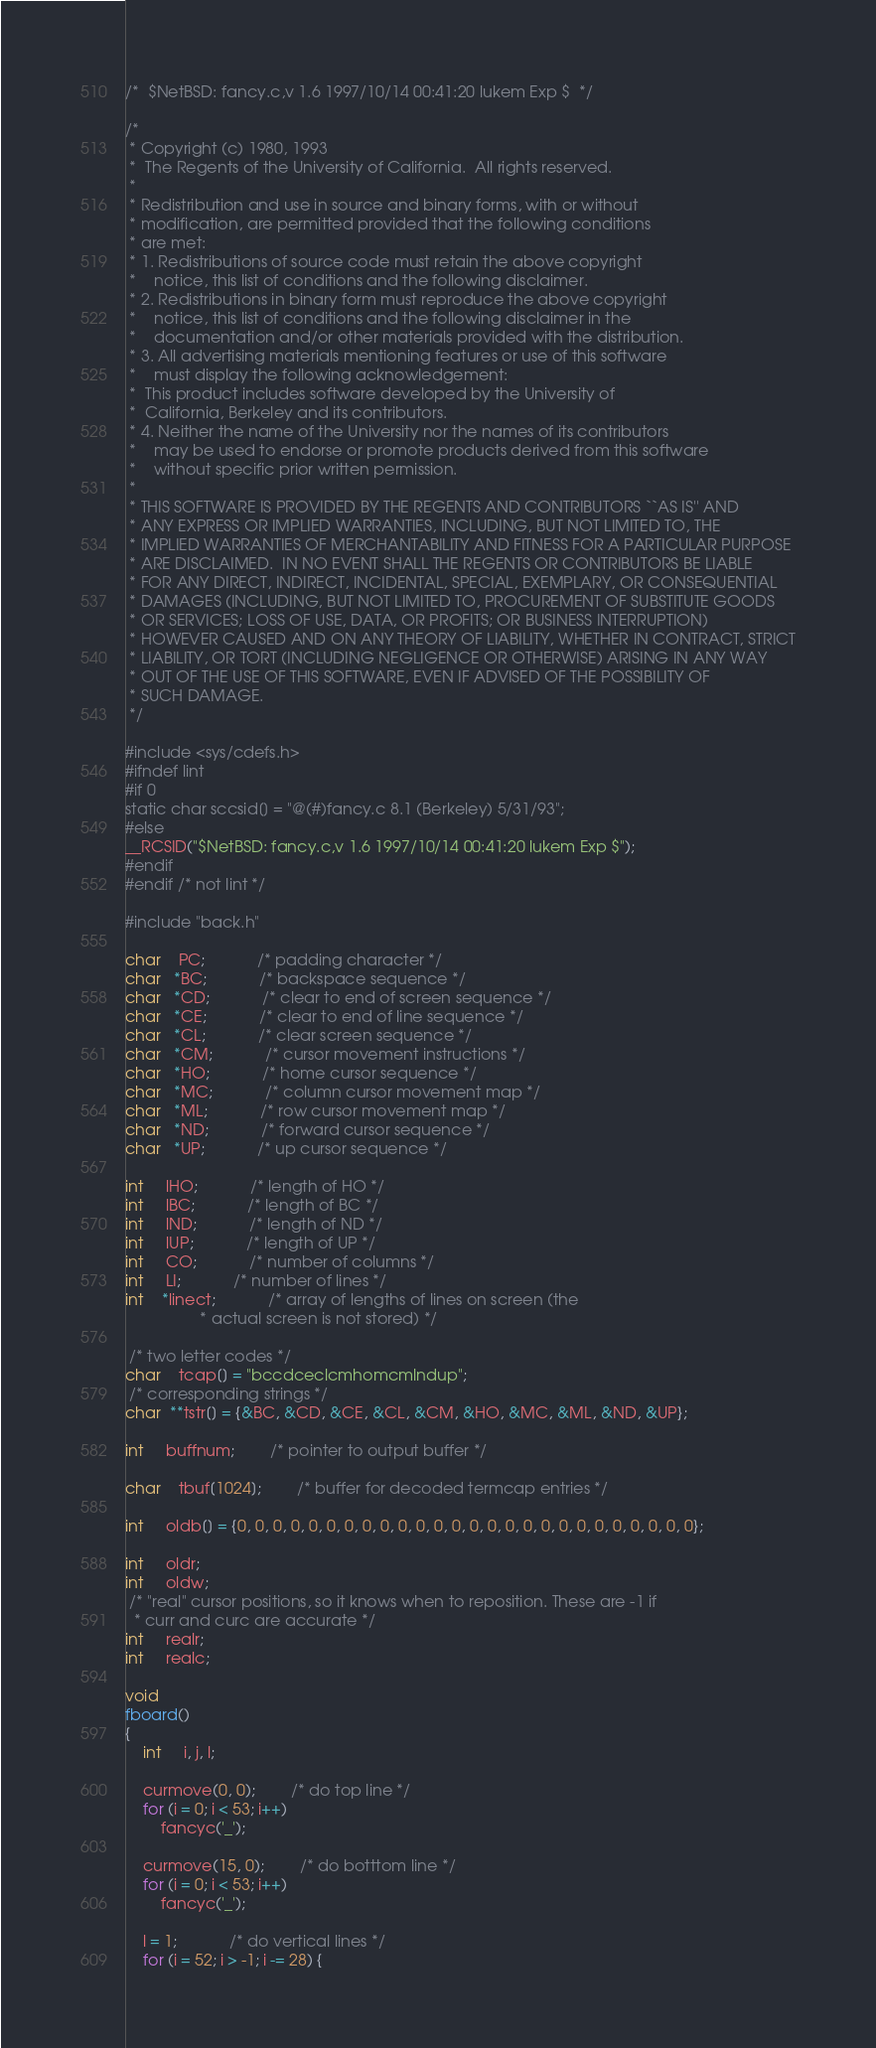<code> <loc_0><loc_0><loc_500><loc_500><_C_>/*	$NetBSD: fancy.c,v 1.6 1997/10/14 00:41:20 lukem Exp $	*/

/*
 * Copyright (c) 1980, 1993
 *	The Regents of the University of California.  All rights reserved.
 *
 * Redistribution and use in source and binary forms, with or without
 * modification, are permitted provided that the following conditions
 * are met:
 * 1. Redistributions of source code must retain the above copyright
 *    notice, this list of conditions and the following disclaimer.
 * 2. Redistributions in binary form must reproduce the above copyright
 *    notice, this list of conditions and the following disclaimer in the
 *    documentation and/or other materials provided with the distribution.
 * 3. All advertising materials mentioning features or use of this software
 *    must display the following acknowledgement:
 *	This product includes software developed by the University of
 *	California, Berkeley and its contributors.
 * 4. Neither the name of the University nor the names of its contributors
 *    may be used to endorse or promote products derived from this software
 *    without specific prior written permission.
 *
 * THIS SOFTWARE IS PROVIDED BY THE REGENTS AND CONTRIBUTORS ``AS IS'' AND
 * ANY EXPRESS OR IMPLIED WARRANTIES, INCLUDING, BUT NOT LIMITED TO, THE
 * IMPLIED WARRANTIES OF MERCHANTABILITY AND FITNESS FOR A PARTICULAR PURPOSE
 * ARE DISCLAIMED.  IN NO EVENT SHALL THE REGENTS OR CONTRIBUTORS BE LIABLE
 * FOR ANY DIRECT, INDIRECT, INCIDENTAL, SPECIAL, EXEMPLARY, OR CONSEQUENTIAL
 * DAMAGES (INCLUDING, BUT NOT LIMITED TO, PROCUREMENT OF SUBSTITUTE GOODS
 * OR SERVICES; LOSS OF USE, DATA, OR PROFITS; OR BUSINESS INTERRUPTION)
 * HOWEVER CAUSED AND ON ANY THEORY OF LIABILITY, WHETHER IN CONTRACT, STRICT
 * LIABILITY, OR TORT (INCLUDING NEGLIGENCE OR OTHERWISE) ARISING IN ANY WAY
 * OUT OF THE USE OF THIS SOFTWARE, EVEN IF ADVISED OF THE POSSIBILITY OF
 * SUCH DAMAGE.
 */

#include <sys/cdefs.h>
#ifndef lint
#if 0
static char sccsid[] = "@(#)fancy.c	8.1 (Berkeley) 5/31/93";
#else
__RCSID("$NetBSD: fancy.c,v 1.6 1997/10/14 00:41:20 lukem Exp $");
#endif
#endif /* not lint */

#include "back.h"

char    PC;			/* padding character */
char   *BC;			/* backspace sequence */
char   *CD;			/* clear to end of screen sequence */
char   *CE;			/* clear to end of line sequence */
char   *CL;			/* clear screen sequence */
char   *CM;			/* cursor movement instructions */
char   *HO;			/* home cursor sequence */
char   *MC;			/* column cursor movement map */
char   *ML;			/* row cursor movement map */
char   *ND;			/* forward cursor sequence */
char   *UP;			/* up cursor sequence */

int     lHO;			/* length of HO */
int     lBC;			/* length of BC */
int     lND;			/* length of ND */
int     lUP;			/* length of UP */
int     CO;			/* number of columns */
int     LI;			/* number of lines */
int    *linect;			/* array of lengths of lines on screen (the
				 * actual screen is not stored) */

 /* two letter codes */
char    tcap[] = "bccdceclcmhomcmlndup";
 /* corresponding strings */
char  **tstr[] = {&BC, &CD, &CE, &CL, &CM, &HO, &MC, &ML, &ND, &UP};

int     buffnum;		/* pointer to output buffer */

char    tbuf[1024];		/* buffer for decoded termcap entries */

int     oldb[] = {0, 0, 0, 0, 0, 0, 0, 0, 0, 0, 0, 0, 0, 0, 0, 0, 0, 0, 0, 0, 0, 0, 0, 0, 0, 0};

int     oldr;
int     oldw;
 /* "real" cursor positions, so it knows when to reposition. These are -1 if
  * curr and curc are accurate */
int     realr;
int     realc;

void
fboard()
{
	int     i, j, l;

	curmove(0, 0);		/* do top line */
	for (i = 0; i < 53; i++)
		fancyc('_');

	curmove(15, 0);		/* do botttom line */
	for (i = 0; i < 53; i++)
		fancyc('_');

	l = 1;			/* do vertical lines */
	for (i = 52; i > -1; i -= 28) {</code> 